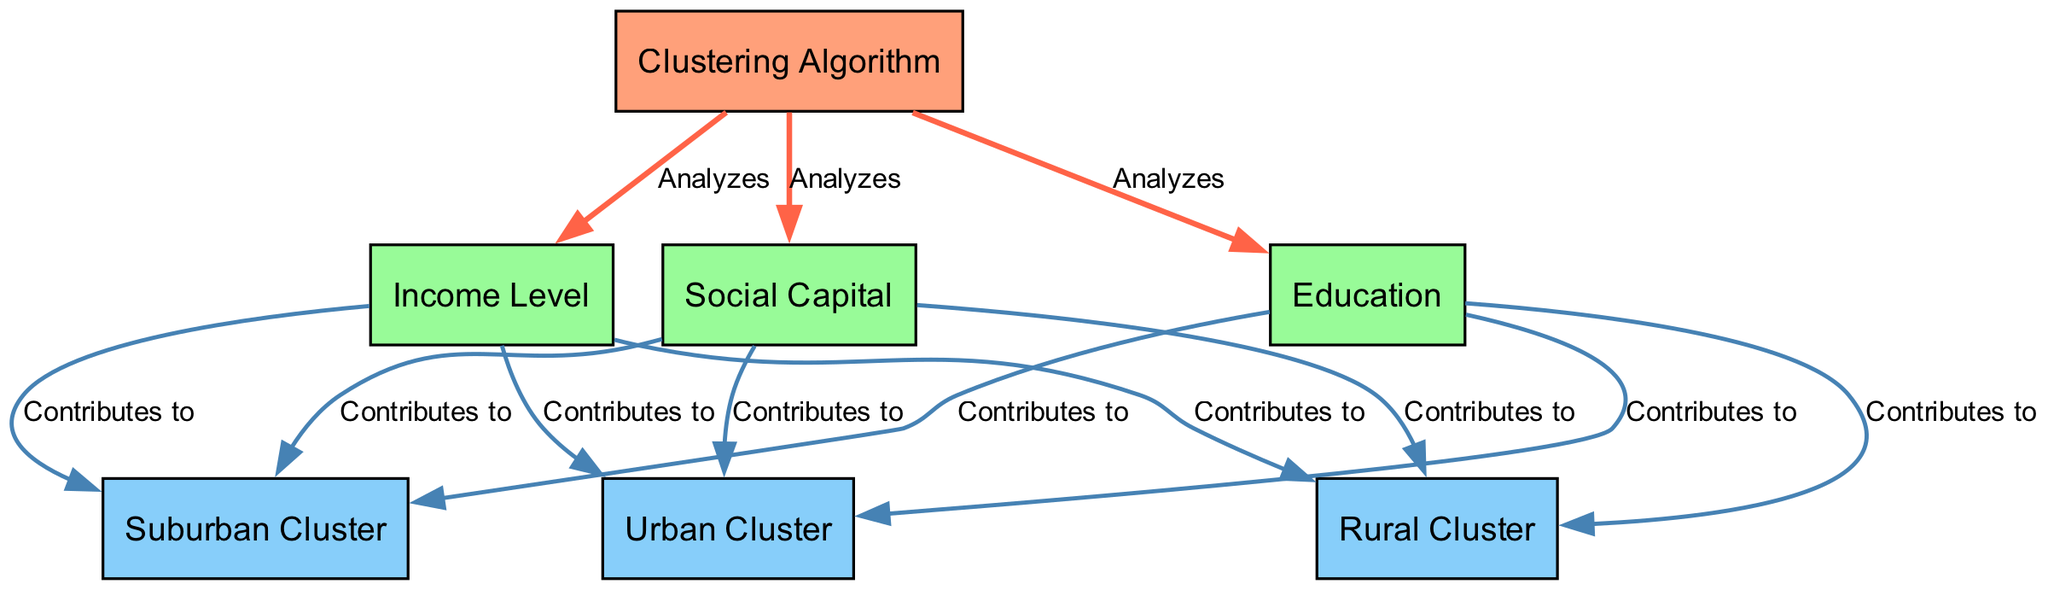What is the main function of the clustering algorithm? The clustering algorithm analyzes income level, education, and social capital to identify groups based on similarities in these characteristics.
Answer: Analyzes How many factors contribute to the urban cluster? The urban cluster is influenced by three factors: income level, education, and social capital, which all contribute to it.
Answer: 3 Which node is directly linked to the clustering algorithm? The nodes income level, education, and social capital are all directly linked to the clustering algorithm, indicating their role in the analysis process.
Answer: Income Level, Education, Social Capital What color represents the clustering algorithm in the diagram? The clustering algorithm is represented in a coral color (#FFA07A), distinguishing it from the other elements of the diagram.
Answer: Coral How do education and social capital relate to the suburban cluster? Both education and social capital contribute to the suburban cluster, indicating that they play a role in the characteristics of communities within suburban areas.
Answer: Contributes to Are there any factors that contribute to both urban and suburban clusters? Yes, income level, education, and social capital each contribute to both the urban and suburban clusters, indicating shared characteristics that define these communities.
Answer: Yes What type of relationships are indicated by the edges that connect the clustering algorithm to its input nodes? The edges indicate an 'analyzes' relationship, showing that the clustering algorithm assesses the input nodes (income level, education, social capital) to identify groupings.
Answer: Analyzes Which clusters are influenced by education? Education contributes to urban, suburban, and rural clusters, indicating its wide-reaching effect on community characteristics across different settings.
Answer: Urban Cluster, Suburban Cluster, Rural Cluster 